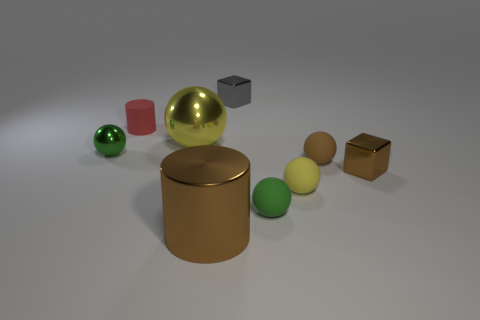Subtract all brown balls. How many balls are left? 4 Subtract all yellow metal spheres. How many spheres are left? 4 Subtract all red balls. Subtract all brown blocks. How many balls are left? 5 Add 1 big cylinders. How many objects exist? 10 Subtract all blocks. How many objects are left? 7 Subtract 0 red cubes. How many objects are left? 9 Subtract all large brown spheres. Subtract all tiny brown matte objects. How many objects are left? 8 Add 8 tiny green matte balls. How many tiny green matte balls are left? 9 Add 4 small red things. How many small red things exist? 5 